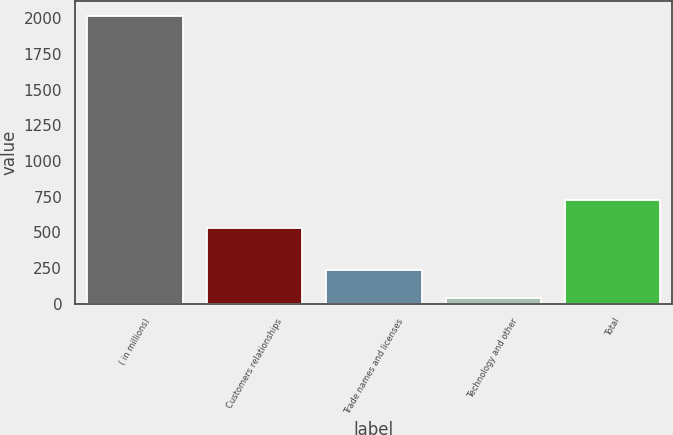<chart> <loc_0><loc_0><loc_500><loc_500><bar_chart><fcel>( in millions)<fcel>Customers relationships<fcel>Trade names and licenses<fcel>Technology and other<fcel>Total<nl><fcel>2018<fcel>530<fcel>237.8<fcel>40<fcel>727.8<nl></chart> 